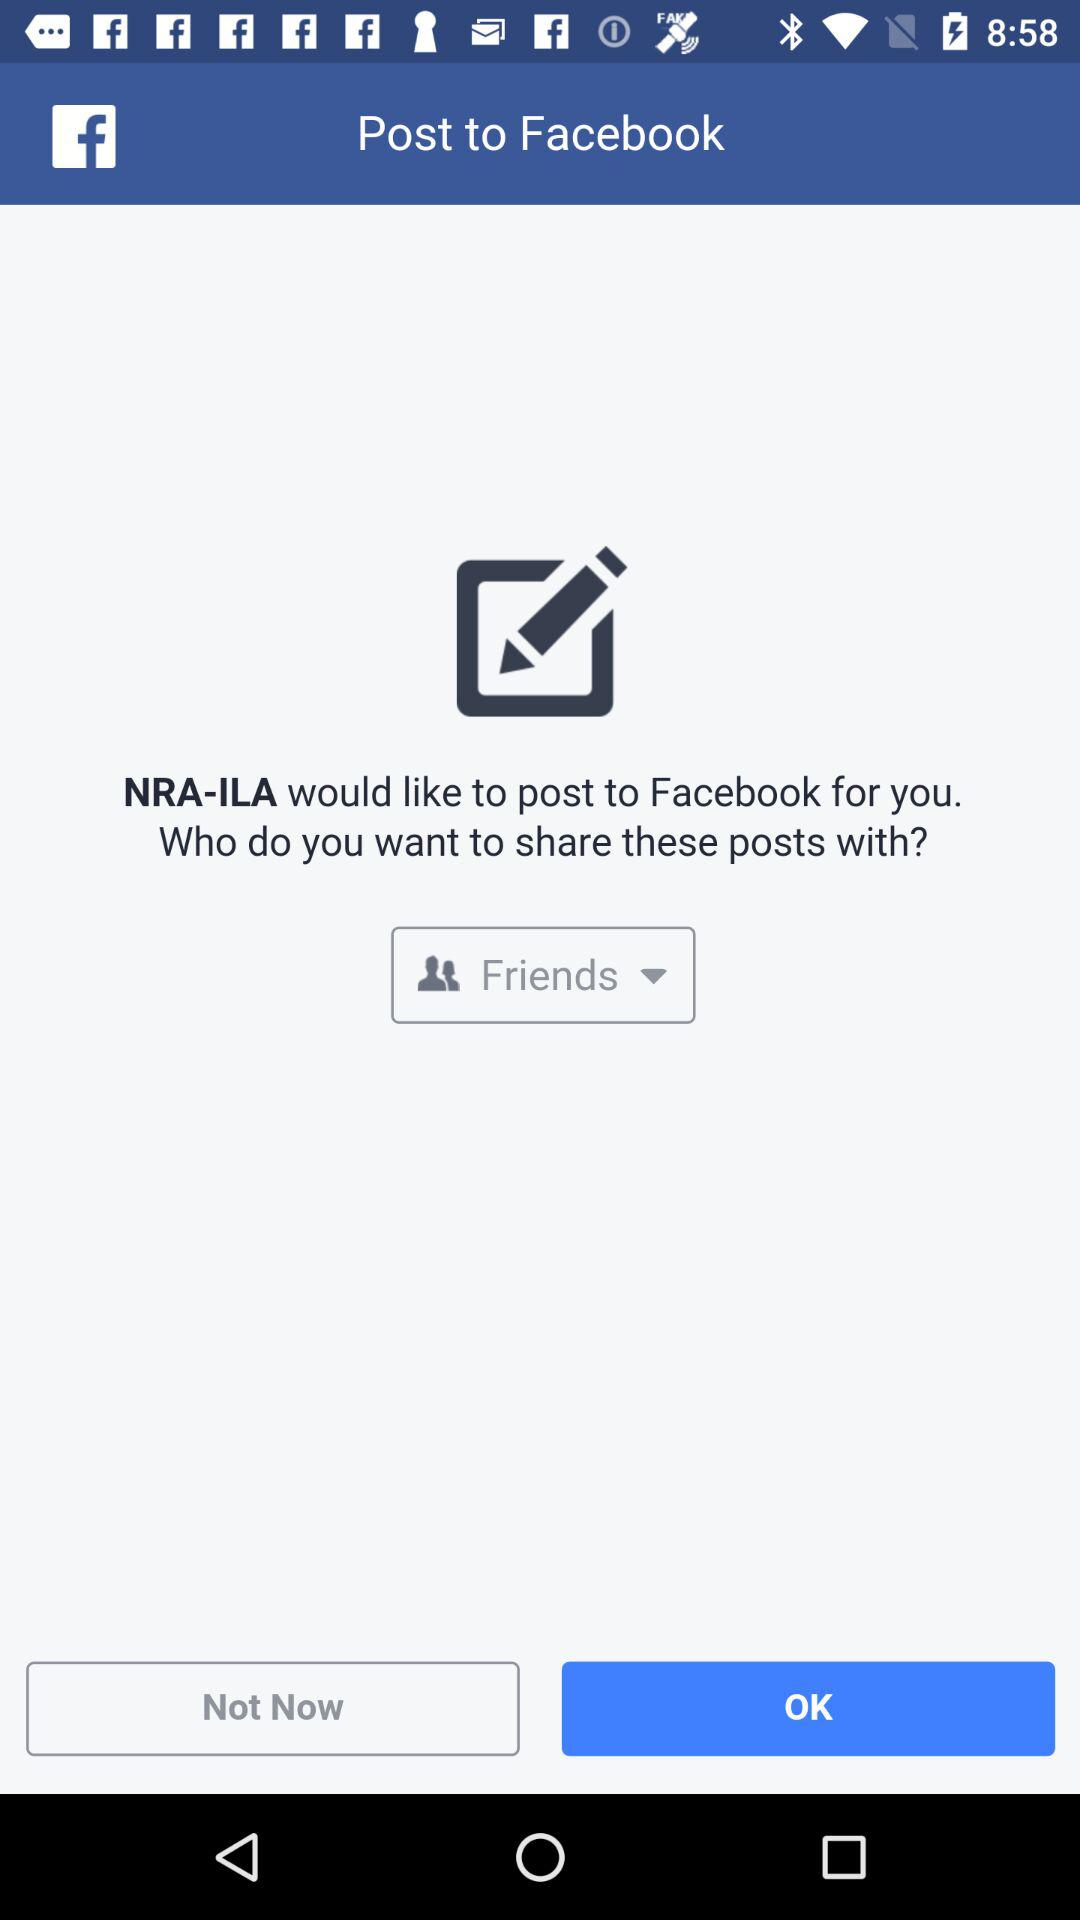What is the selected privacy for sharing the post? The selected privacy is "Friends". 